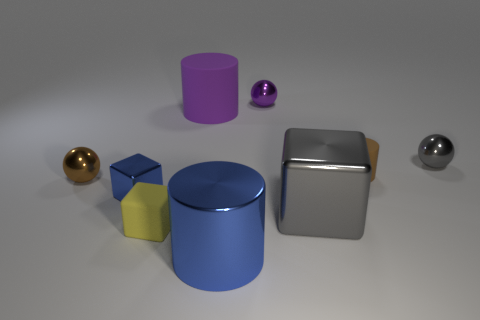Is there any other thing that is the same size as the brown matte object?
Provide a succinct answer. Yes. There is a blue object that is the same shape as the small brown matte thing; what is it made of?
Give a very brief answer. Metal. Is there a gray cube left of the small sphere to the left of the small sphere that is behind the large purple thing?
Offer a very short reply. No. There is a tiny matte object that is right of the purple ball; does it have the same shape as the gray shiny thing that is to the left of the gray metallic ball?
Provide a short and direct response. No. Is the number of tiny brown cylinders that are right of the purple sphere greater than the number of small blue metallic things?
Ensure brevity in your answer.  No. How many objects are tiny brown objects or big blue cylinders?
Give a very brief answer. 3. What is the color of the big cube?
Make the answer very short. Gray. What number of other objects are the same color as the big cube?
Make the answer very short. 1. Are there any small brown rubber cylinders to the left of the small brown cylinder?
Keep it short and to the point. No. What color is the cylinder that is behind the small matte object behind the ball on the left side of the tiny yellow cube?
Make the answer very short. Purple. 